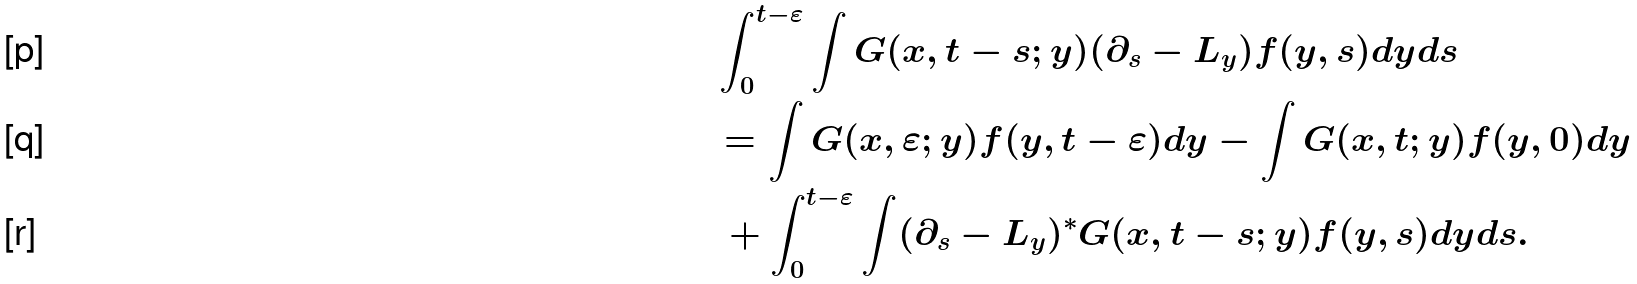<formula> <loc_0><loc_0><loc_500><loc_500>& \int _ { 0 } ^ { t - \varepsilon } \int G ( x , t - s ; y ) ( \partial _ { s } - L _ { y } ) f ( y , s ) d y d s \\ & = \int G ( x , \varepsilon ; y ) f ( y , t - \varepsilon ) d y - \int G ( x , t ; y ) f ( y , 0 ) d y \\ & \, + \int _ { 0 } ^ { t - \varepsilon } \int ( \partial _ { s } - L _ { y } ) ^ { * } G ( x , t - s ; y ) f ( y , s ) d y d s .</formula> 